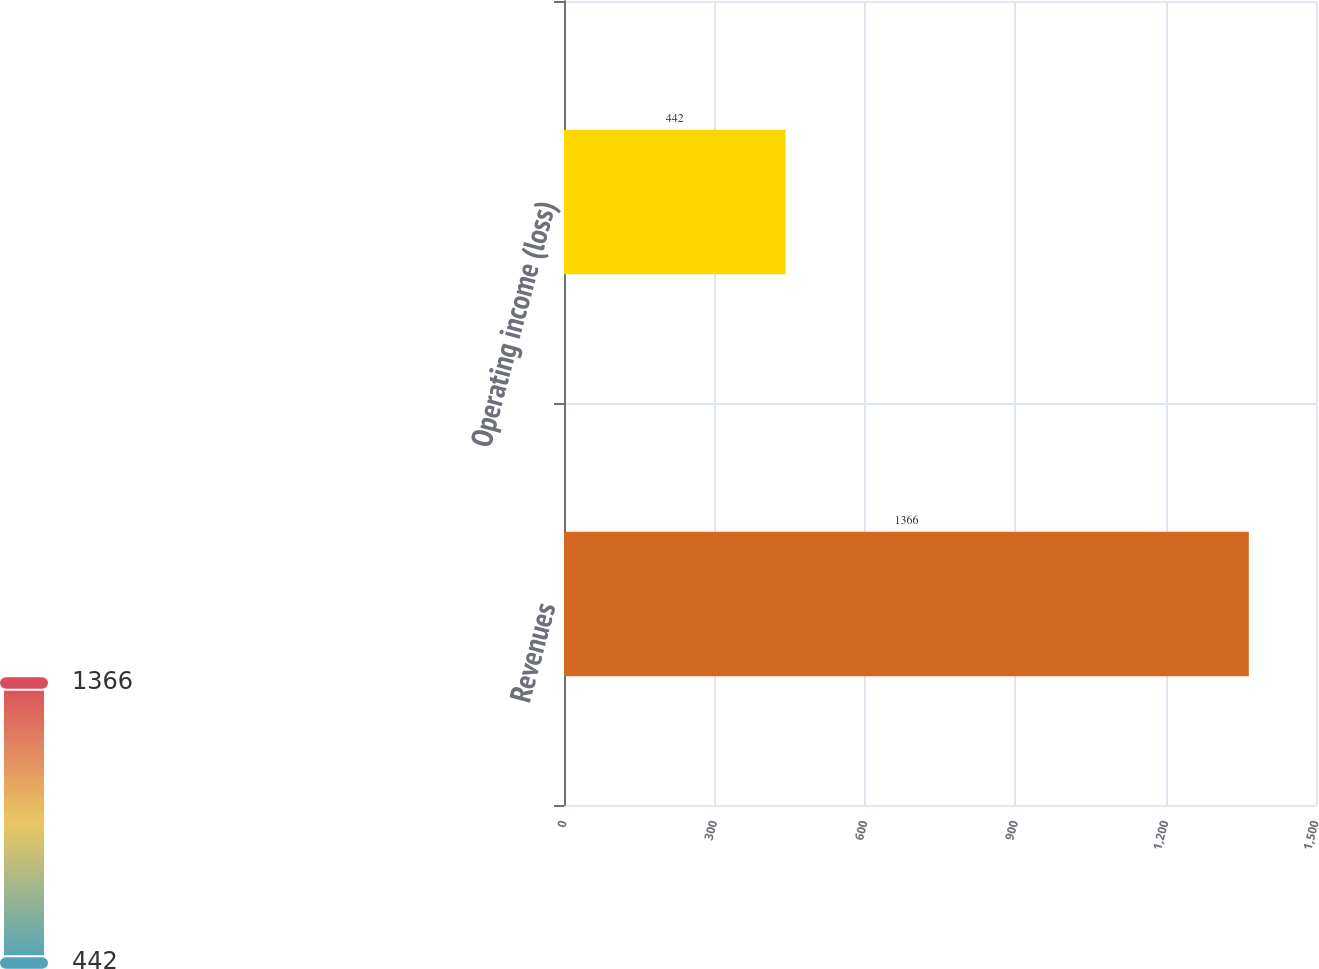Convert chart. <chart><loc_0><loc_0><loc_500><loc_500><bar_chart><fcel>Revenues<fcel>Operating income (loss)<nl><fcel>1366<fcel>442<nl></chart> 